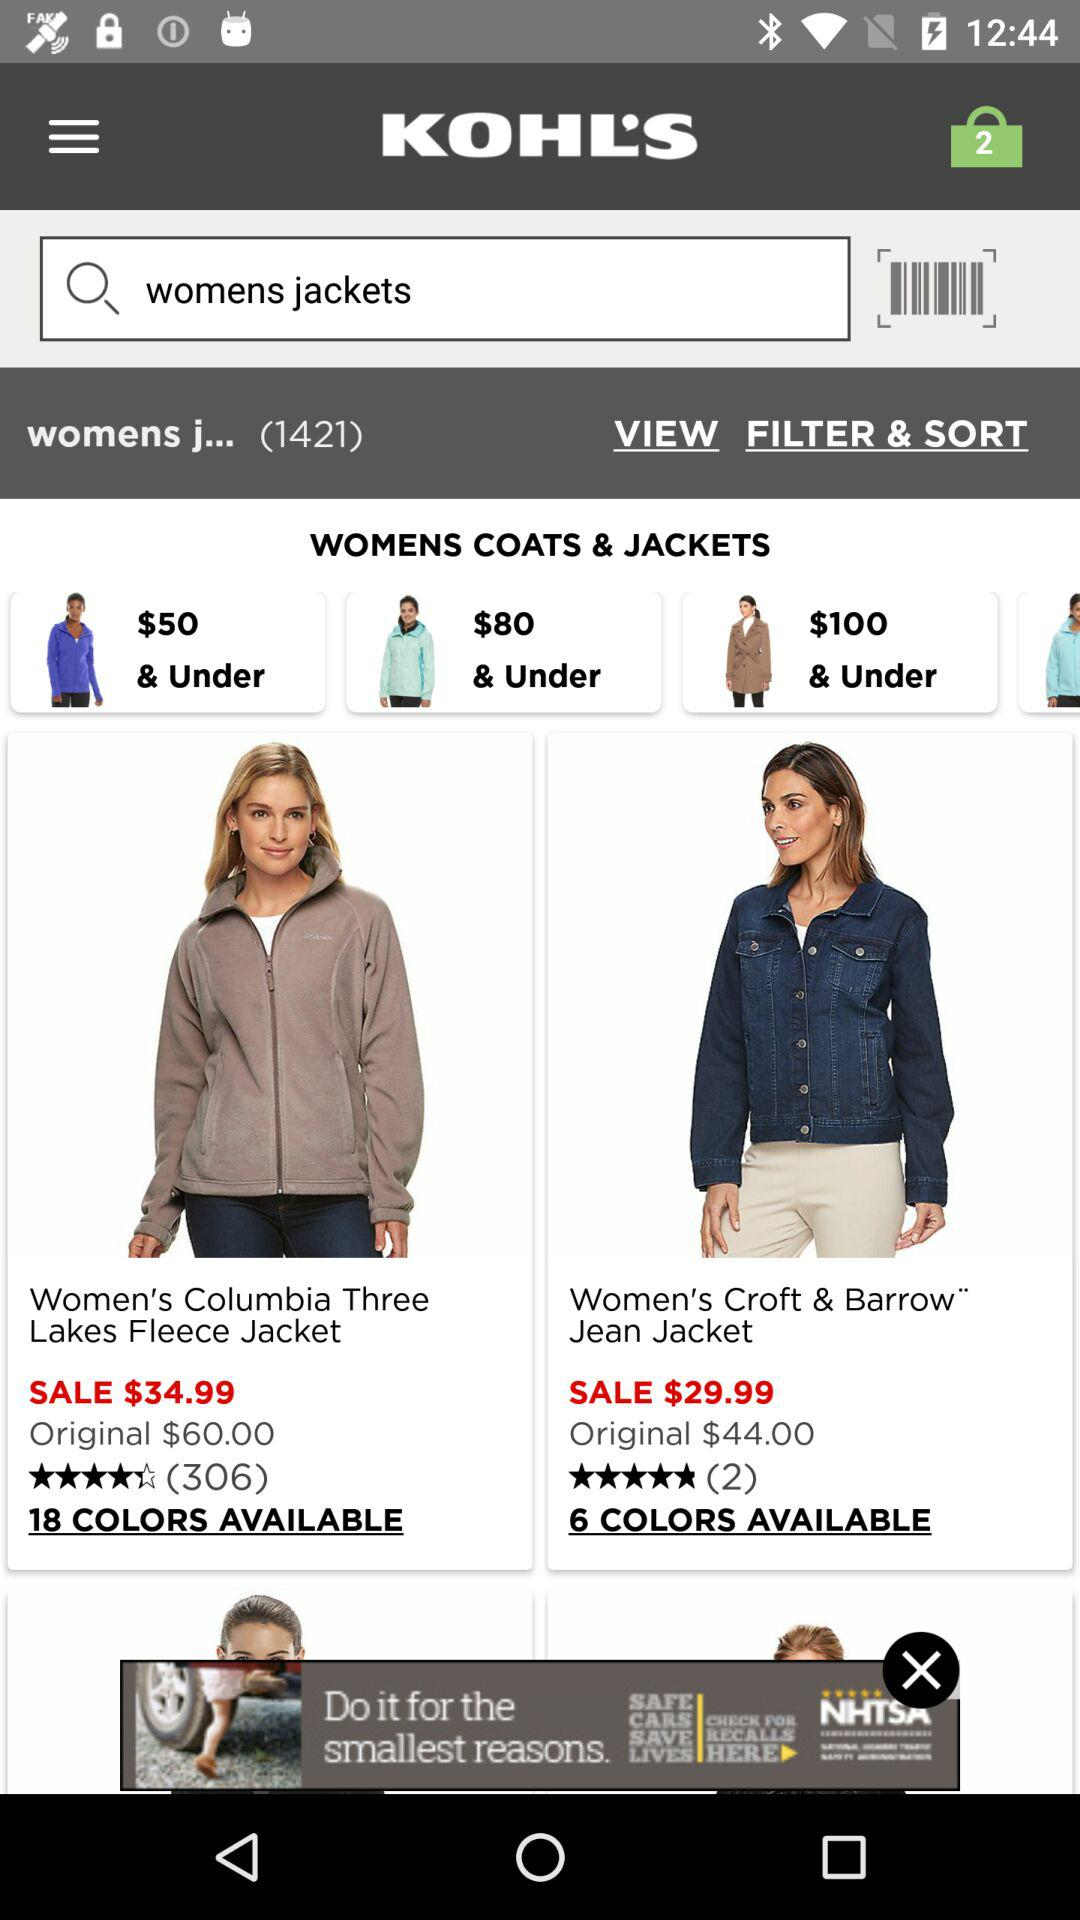How many colors are available in "Women's Columbia Three Lakes Fleece Jacket"? There are 18 colors available. 